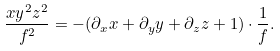<formula> <loc_0><loc_0><loc_500><loc_500>\frac { x y ^ { 2 } z ^ { 2 } } { f ^ { 2 } } = - ( \partial _ { x } x + \partial _ { y } y + \partial _ { z } z + 1 ) \cdot \frac { 1 } { f } .</formula> 